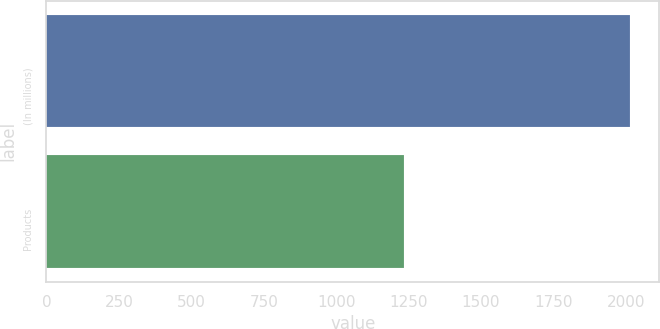Convert chart to OTSL. <chart><loc_0><loc_0><loc_500><loc_500><bar_chart><fcel>(In millions)<fcel>Products<nl><fcel>2015<fcel>1234<nl></chart> 